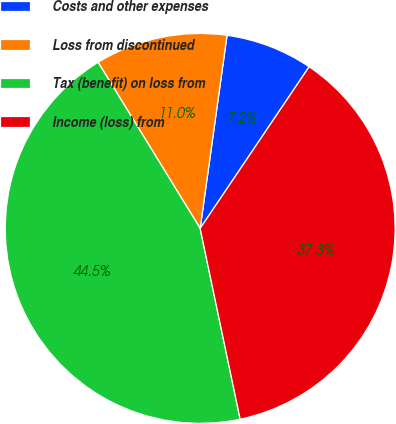<chart> <loc_0><loc_0><loc_500><loc_500><pie_chart><fcel>Costs and other expenses<fcel>Loss from discontinued<fcel>Tax (benefit) on loss from<fcel>Income (loss) from<nl><fcel>7.24%<fcel>10.97%<fcel>44.52%<fcel>37.27%<nl></chart> 